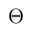<formula> <loc_0><loc_0><loc_500><loc_500>\Theta</formula> 